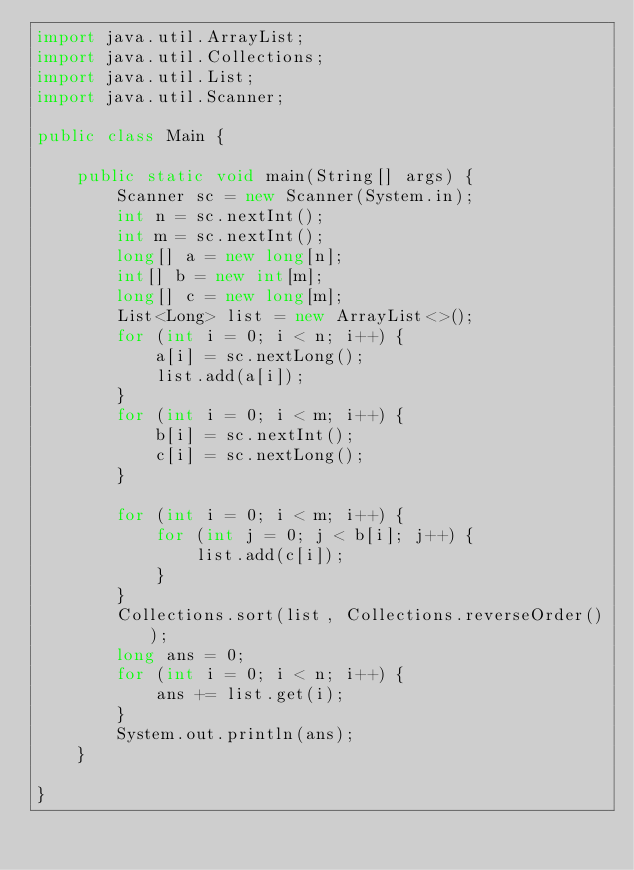<code> <loc_0><loc_0><loc_500><loc_500><_Java_>import java.util.ArrayList;
import java.util.Collections;
import java.util.List;
import java.util.Scanner;

public class Main {

    public static void main(String[] args) {
        Scanner sc = new Scanner(System.in);
        int n = sc.nextInt();
        int m = sc.nextInt();
        long[] a = new long[n];
        int[] b = new int[m];
        long[] c = new long[m];
        List<Long> list = new ArrayList<>();
        for (int i = 0; i < n; i++) {
            a[i] = sc.nextLong();
            list.add(a[i]);
        }
        for (int i = 0; i < m; i++) {
            b[i] = sc.nextInt();
            c[i] = sc.nextLong();
        }

        for (int i = 0; i < m; i++) {
            for (int j = 0; j < b[i]; j++) {
                list.add(c[i]);
            }
        }
        Collections.sort(list, Collections.reverseOrder());
        long ans = 0;
        for (int i = 0; i < n; i++) {
            ans += list.get(i);
        }
        System.out.println(ans);
    }

}
</code> 